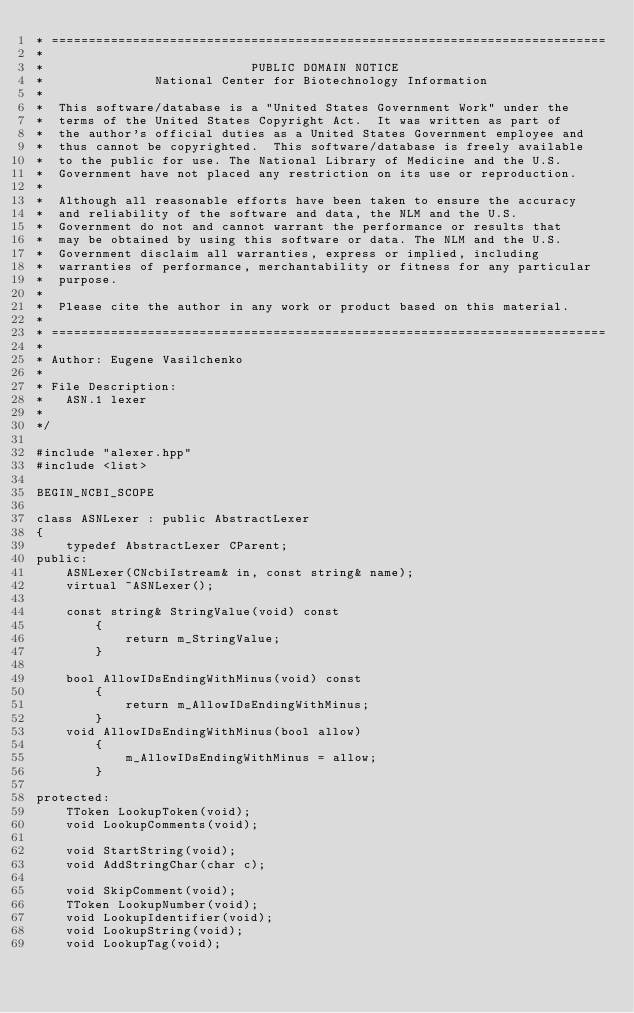<code> <loc_0><loc_0><loc_500><loc_500><_C++_>* ===========================================================================
*
*                            PUBLIC DOMAIN NOTICE
*               National Center for Biotechnology Information
*
*  This software/database is a "United States Government Work" under the
*  terms of the United States Copyright Act.  It was written as part of
*  the author's official duties as a United States Government employee and
*  thus cannot be copyrighted.  This software/database is freely available
*  to the public for use. The National Library of Medicine and the U.S.
*  Government have not placed any restriction on its use or reproduction.
*
*  Although all reasonable efforts have been taken to ensure the accuracy
*  and reliability of the software and data, the NLM and the U.S.
*  Government do not and cannot warrant the performance or results that
*  may be obtained by using this software or data. The NLM and the U.S.
*  Government disclaim all warranties, express or implied, including
*  warranties of performance, merchantability or fitness for any particular
*  purpose.
*
*  Please cite the author in any work or product based on this material.
*
* ===========================================================================
*
* Author: Eugene Vasilchenko
*
* File Description:
*   ASN.1 lexer
*
*/

#include "alexer.hpp"
#include <list>

BEGIN_NCBI_SCOPE

class ASNLexer : public AbstractLexer
{
    typedef AbstractLexer CParent;
public:
    ASNLexer(CNcbiIstream& in, const string& name);
    virtual ~ASNLexer();

    const string& StringValue(void) const
        {
            return m_StringValue;
        }

    bool AllowIDsEndingWithMinus(void) const
        {
            return m_AllowIDsEndingWithMinus;
        }
    void AllowIDsEndingWithMinus(bool allow)
        {
            m_AllowIDsEndingWithMinus = allow;
        }

protected:
    TToken LookupToken(void);
    void LookupComments(void);

    void StartString(void);
    void AddStringChar(char c);

    void SkipComment(void);
    TToken LookupNumber(void);
    void LookupIdentifier(void);
    void LookupString(void);
    void LookupTag(void);</code> 